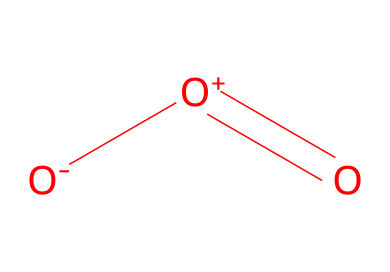how many oxygen atoms are in this molecule? The SMILES representation indicates three oxygen atoms in total: one is negatively charged (O-), one is positively charged (O+), and one is double bonded (O).
Answer: three what type of bonding is present in the ozone molecule? The structure shows one double bond between two oxygen atoms and one single bond involving the charged oxygen atoms. This indicates both double and single bonding is present.
Answer: double and single what is the charge on the central oxygen atom? The SMILES representation indicates that the central oxygen atom has a positive charge (O+), which can be deduced from the notation in the SMILES.
Answer: positive what is the basic function of ozone in air purification systems? Ozone is primarily used as an oxidizing agent that reacts with and neutralizes pollutants and odors in the air, contributing to cleaner air in office spaces.
Answer: oxidizing agent how does the structure of ozone relate to its stability? The presence of a double bond introduces some stability to the molecule; however, the high energy state and the presence of charges suggest that ozone is relatively unstable and reactive compared to diatomic oxygen.
Answer: relatively unstable how does ozone's molecular geometry affect its reactivity? The bent molecular geometry created by the arrangement of oxygen atoms leads to its high reactivity with other substances, as it can easily interact due to its polar nature and the presence of charges.
Answer: polar nature 